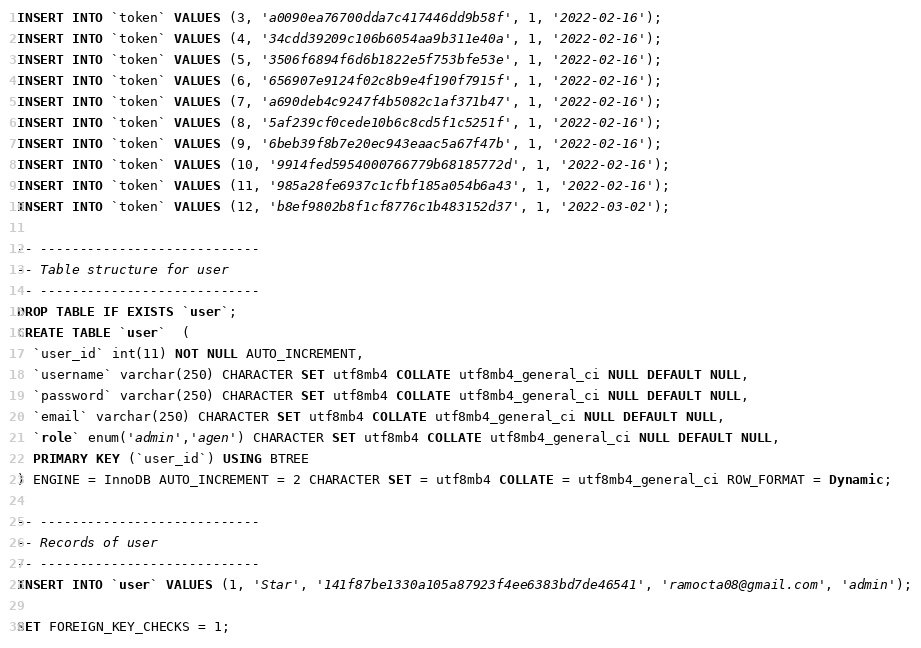<code> <loc_0><loc_0><loc_500><loc_500><_SQL_>INSERT INTO `token` VALUES (3, 'a0090ea76700dda7c417446dd9b58f', 1, '2022-02-16');
INSERT INTO `token` VALUES (4, '34cdd39209c106b6054aa9b311e40a', 1, '2022-02-16');
INSERT INTO `token` VALUES (5, '3506f6894f6d6b1822e5f753bfe53e', 1, '2022-02-16');
INSERT INTO `token` VALUES (6, '656907e9124f02c8b9e4f190f7915f', 1, '2022-02-16');
INSERT INTO `token` VALUES (7, 'a690deb4c9247f4b5082c1af371b47', 1, '2022-02-16');
INSERT INTO `token` VALUES (8, '5af239cf0cede10b6c8cd5f1c5251f', 1, '2022-02-16');
INSERT INTO `token` VALUES (9, '6beb39f8b7e20ec943eaac5a67f47b', 1, '2022-02-16');
INSERT INTO `token` VALUES (10, '9914fed5954000766779b68185772d', 1, '2022-02-16');
INSERT INTO `token` VALUES (11, '985a28fe6937c1cfbf185a054b6a43', 1, '2022-02-16');
INSERT INTO `token` VALUES (12, 'b8ef9802b8f1cf8776c1b483152d37', 1, '2022-03-02');

-- ----------------------------
-- Table structure for user
-- ----------------------------
DROP TABLE IF EXISTS `user`;
CREATE TABLE `user`  (
  `user_id` int(11) NOT NULL AUTO_INCREMENT,
  `username` varchar(250) CHARACTER SET utf8mb4 COLLATE utf8mb4_general_ci NULL DEFAULT NULL,
  `password` varchar(250) CHARACTER SET utf8mb4 COLLATE utf8mb4_general_ci NULL DEFAULT NULL,
  `email` varchar(250) CHARACTER SET utf8mb4 COLLATE utf8mb4_general_ci NULL DEFAULT NULL,
  `role` enum('admin','agen') CHARACTER SET utf8mb4 COLLATE utf8mb4_general_ci NULL DEFAULT NULL,
  PRIMARY KEY (`user_id`) USING BTREE
) ENGINE = InnoDB AUTO_INCREMENT = 2 CHARACTER SET = utf8mb4 COLLATE = utf8mb4_general_ci ROW_FORMAT = Dynamic;

-- ----------------------------
-- Records of user
-- ----------------------------
INSERT INTO `user` VALUES (1, 'Star', '141f87be1330a105a87923f4ee6383bd7de46541', 'ramocta08@gmail.com', 'admin');

SET FOREIGN_KEY_CHECKS = 1;
</code> 